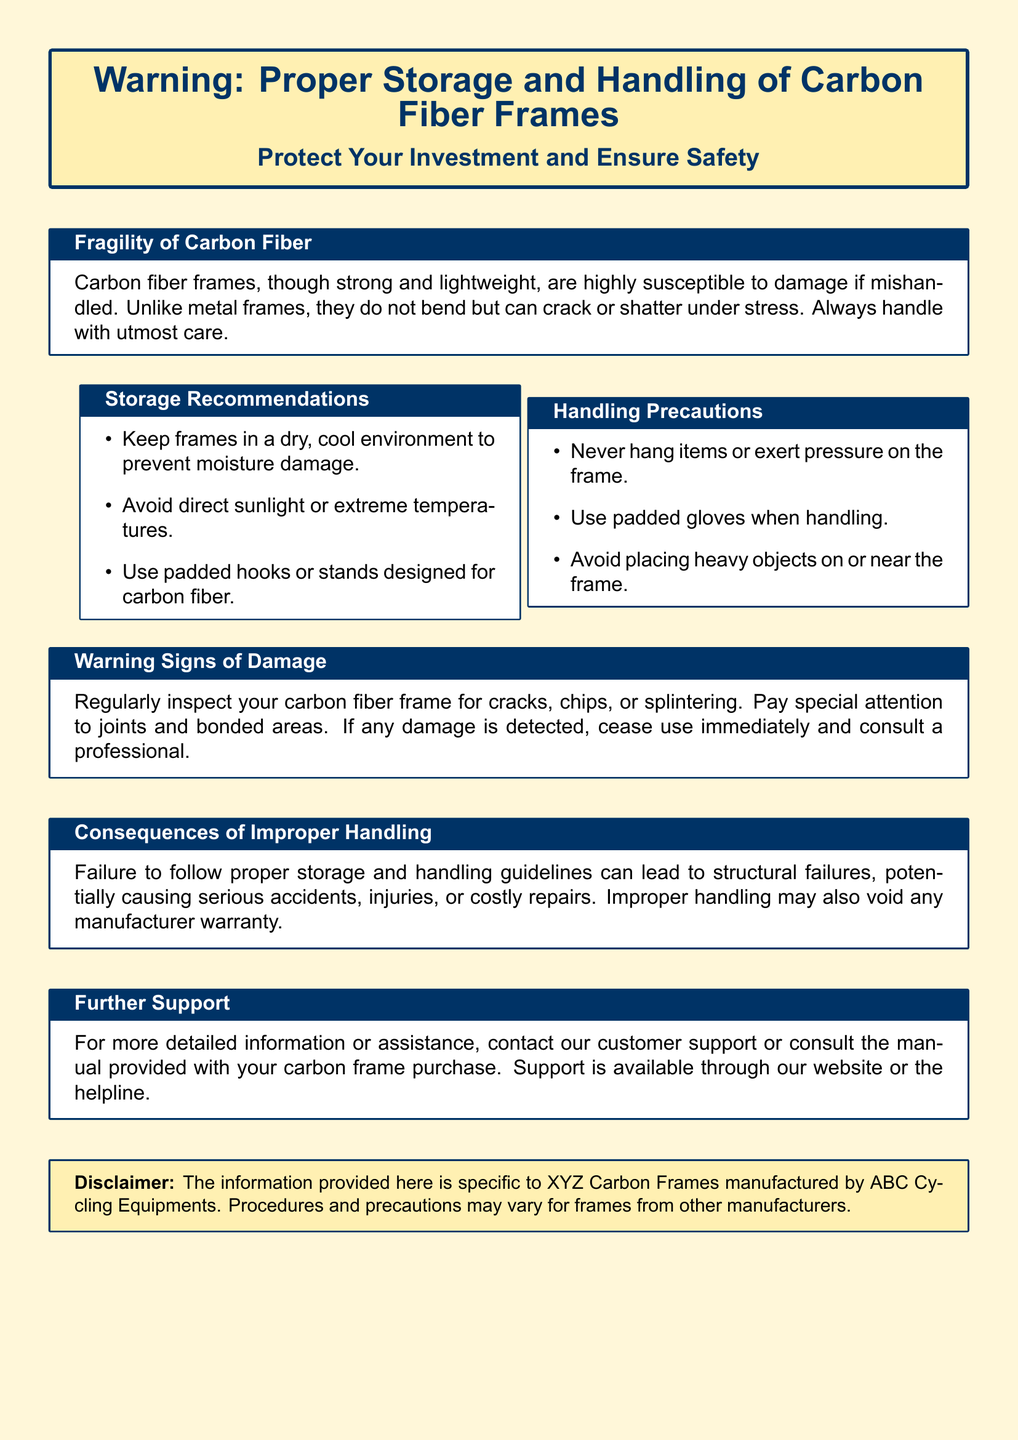What is the main material of the frames? The document states that carbon fiber is the main material used for the frames.
Answer: carbon fiber What type of environment should frames be stored in? The document recommends keeping frames in a dry, cool environment.
Answer: dry, cool environment What are the warning signs of damage? The document lists cracks, chips, or splintering as warning signs of damage.
Answer: cracks, chips, or splintering What should be avoided when handling the frame? The document advises avoiding heavy objects being placed on or near the frame.
Answer: heavy objects What can improper handling potentially void? The document states that improper handling may void any manufacturer warranty.
Answer: manufacturer warranty What should you do if damage is detected? The document advises ceasing use immediately and consulting a professional if damage is found.
Answer: cease use immediately and consult a professional Which item is recommended for handling the frame? The document suggests using padded gloves when handling the frame.
Answer: padded gloves What type of precautions does the handling section emphasize? The handling section emphasizes using precautions to avoid exerting pressure on the frame.
Answer: precautions 